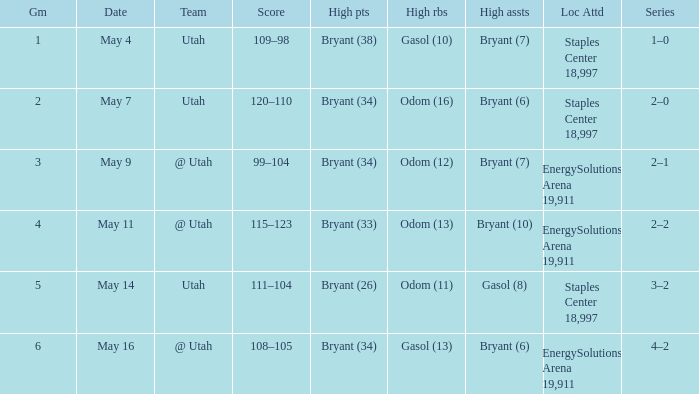What is the High rebounds with a High assists with bryant (7), and a Team of @ utah? Odom (12). 